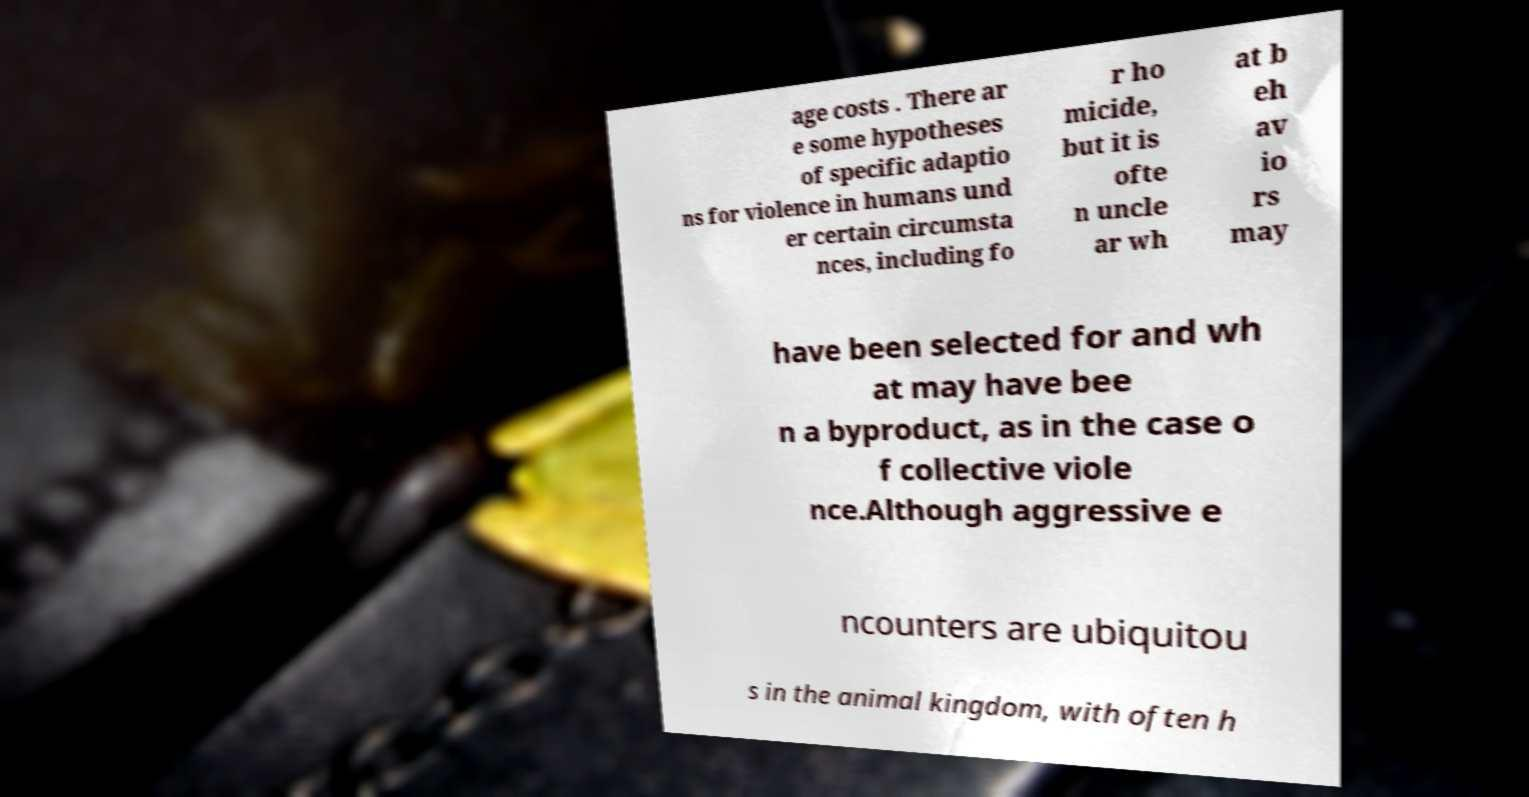Please read and relay the text visible in this image. What does it say? age costs . There ar e some hypotheses of specific adaptio ns for violence in humans und er certain circumsta nces, including fo r ho micide, but it is ofte n uncle ar wh at b eh av io rs may have been selected for and wh at may have bee n a byproduct, as in the case o f collective viole nce.Although aggressive e ncounters are ubiquitou s in the animal kingdom, with often h 